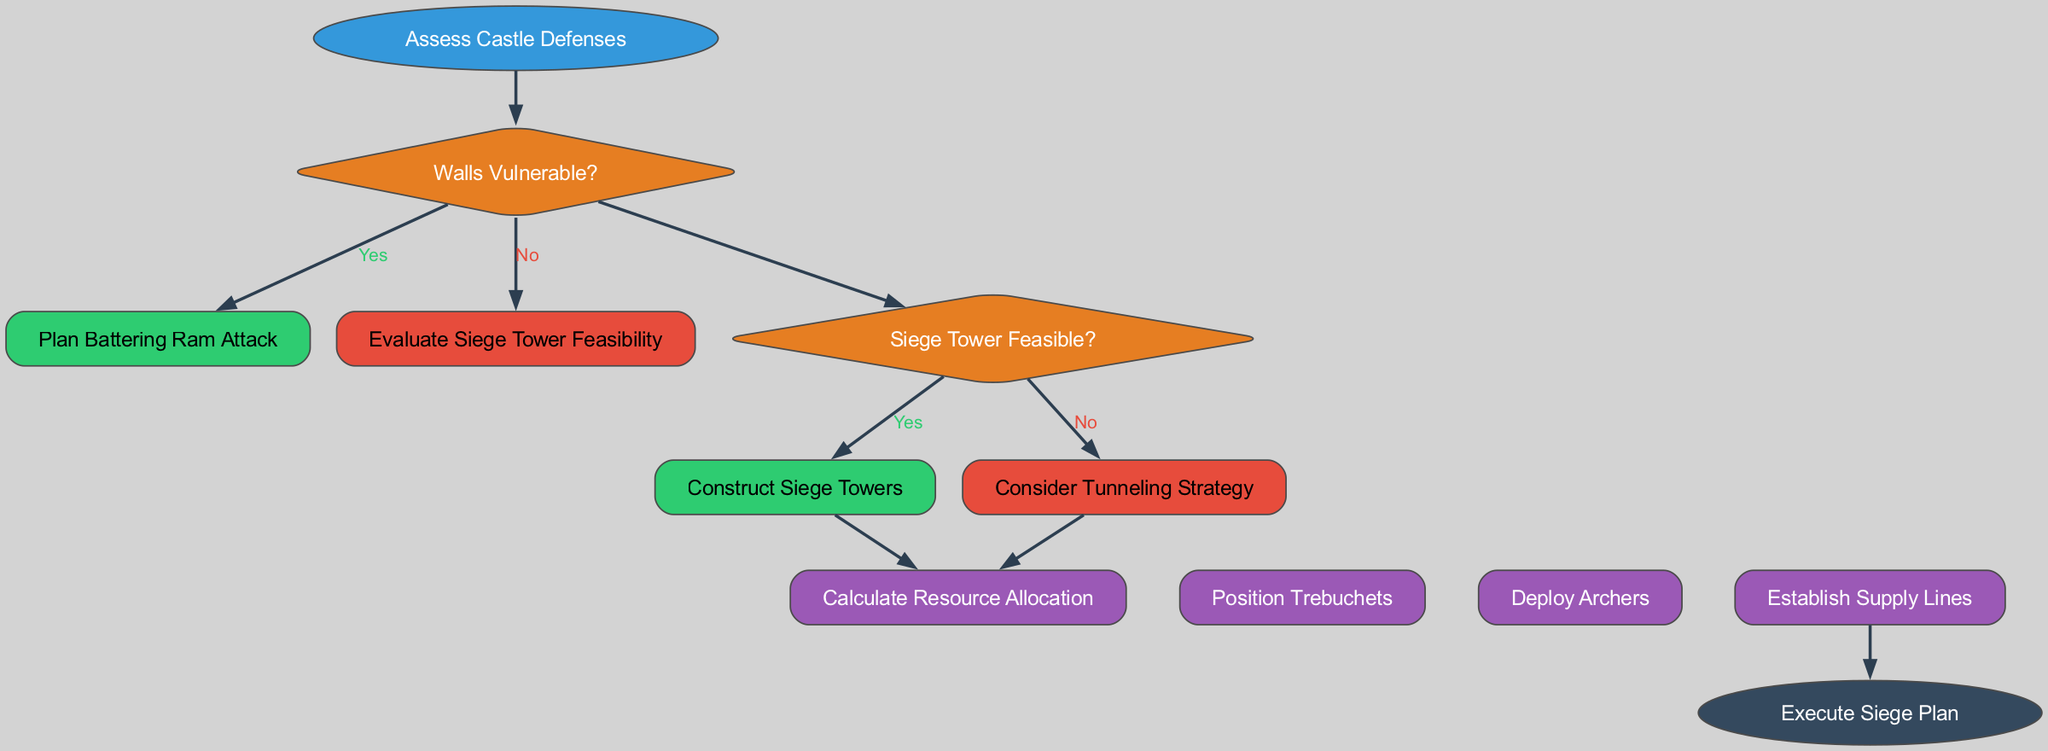What is the first step in the battle strategy planning? The first step in the battle strategy planning is to "Assess Castle Defenses," as indicated at the start of the diagram.
Answer: Assess Castle Defenses How many decision nodes are present in the diagram? There are two decision nodes: one for "Walls Vulnerable?" and another for "Siege Tower Feasible?" This can be counted directly from the diagram.
Answer: 2 What action follows if the Siege Tower is feasible? If the Siege Tower is feasible, the next action is "Construct Siege Towers," which is directly linked from the corresponding decision node in the diagram.
Answer: Construct Siege Towers What happens if the Walls are not vulnerable? If the Walls are not vulnerable, the flow leads to "Evaluate Siege Tower Feasibility," which indicates a consideration of the next strategic option based on the vulnerability of the walls.
Answer: Evaluate Siege Tower Feasibility What action joins the end of the last action node before the execution of the siege plan? The last action before the execution of the siege plan is "Deploy Archers," which connects directly to the end node.
Answer: Deploy Archers If the Siege Tower is not feasible, what strategy is considered next? If the Siege Tower is not feasible, the next strategy considered is "Consider Tunneling Strategy," stemming from that decision point in the flow.
Answer: Consider Tunneling Strategy What do you need to calculate before deploying the archers? Before deploying the archers, it's necessary to "Calculate Resource Allocation," which is one of the earlier actions outlined in the diagram.
Answer: Calculate Resource Allocation Which decision leads to the action of establishing supply lines? The actions listed are parallel and deciding on the walls or towers does not specifically dictate establishing supply lines, but it will still happen as it’s one of the earlier actions executed regardless of which path is taken in the decision.
Answer: Actions executed together What color represents the action nodes in the diagram? The action nodes are represented in a purple color (#9b59b6) as specified in the styling section of the diagram creation code.
Answer: Purple 